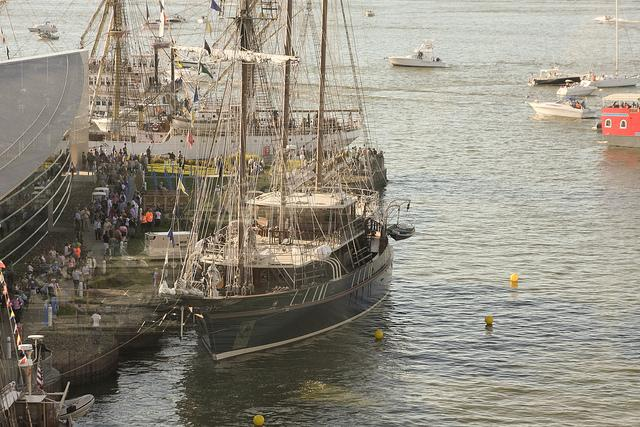How many sail posts are on the back of this historic sailing ship? one 